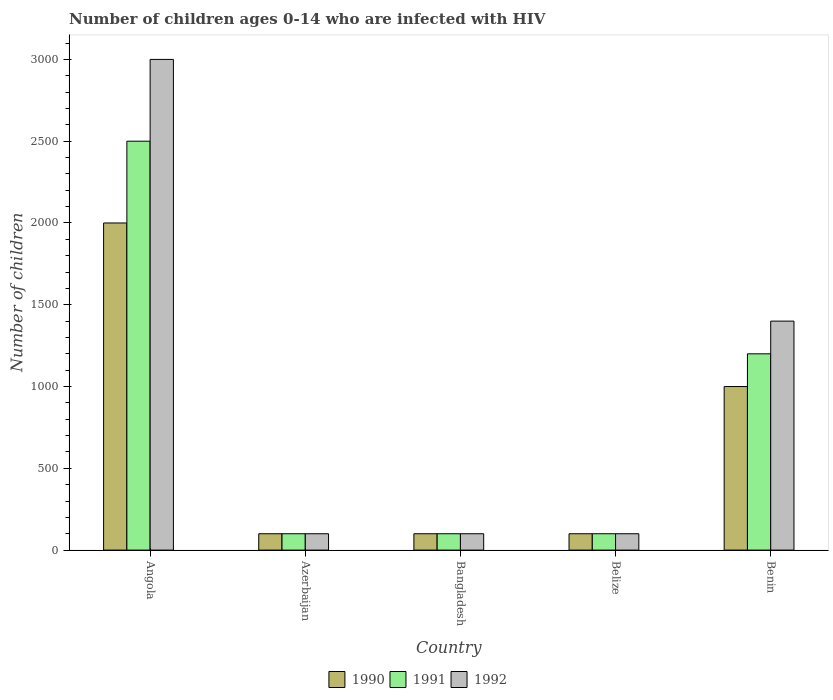How many groups of bars are there?
Your answer should be compact. 5. How many bars are there on the 1st tick from the left?
Your answer should be very brief. 3. How many bars are there on the 2nd tick from the right?
Offer a very short reply. 3. What is the label of the 1st group of bars from the left?
Your response must be concise. Angola. In how many cases, is the number of bars for a given country not equal to the number of legend labels?
Offer a terse response. 0. What is the number of HIV infected children in 1992 in Bangladesh?
Ensure brevity in your answer.  100. Across all countries, what is the maximum number of HIV infected children in 1992?
Give a very brief answer. 3000. Across all countries, what is the minimum number of HIV infected children in 1990?
Give a very brief answer. 100. In which country was the number of HIV infected children in 1990 maximum?
Provide a short and direct response. Angola. In which country was the number of HIV infected children in 1990 minimum?
Keep it short and to the point. Azerbaijan. What is the total number of HIV infected children in 1991 in the graph?
Your answer should be compact. 4000. What is the difference between the number of HIV infected children in 1991 in Angola and that in Azerbaijan?
Your answer should be very brief. 2400. What is the difference between the number of HIV infected children in 1990 in Benin and the number of HIV infected children in 1992 in Bangladesh?
Offer a very short reply. 900. What is the average number of HIV infected children in 1992 per country?
Provide a short and direct response. 940. What is the difference between the number of HIV infected children of/in 1992 and number of HIV infected children of/in 1991 in Belize?
Provide a short and direct response. 0. Is the difference between the number of HIV infected children in 1992 in Azerbaijan and Bangladesh greater than the difference between the number of HIV infected children in 1991 in Azerbaijan and Bangladesh?
Your response must be concise. No. What is the difference between the highest and the second highest number of HIV infected children in 1992?
Give a very brief answer. 2900. What is the difference between the highest and the lowest number of HIV infected children in 1991?
Provide a succinct answer. 2400. In how many countries, is the number of HIV infected children in 1990 greater than the average number of HIV infected children in 1990 taken over all countries?
Your response must be concise. 2. What does the 2nd bar from the right in Azerbaijan represents?
Give a very brief answer. 1991. Is it the case that in every country, the sum of the number of HIV infected children in 1990 and number of HIV infected children in 1991 is greater than the number of HIV infected children in 1992?
Your answer should be very brief. Yes. How many bars are there?
Make the answer very short. 15. Are all the bars in the graph horizontal?
Ensure brevity in your answer.  No. Does the graph contain grids?
Provide a short and direct response. No. Where does the legend appear in the graph?
Provide a succinct answer. Bottom center. How many legend labels are there?
Your answer should be compact. 3. How are the legend labels stacked?
Provide a short and direct response. Horizontal. What is the title of the graph?
Give a very brief answer. Number of children ages 0-14 who are infected with HIV. What is the label or title of the X-axis?
Your response must be concise. Country. What is the label or title of the Y-axis?
Ensure brevity in your answer.  Number of children. What is the Number of children of 1991 in Angola?
Your answer should be compact. 2500. What is the Number of children in 1992 in Angola?
Provide a short and direct response. 3000. What is the Number of children of 1991 in Azerbaijan?
Offer a very short reply. 100. What is the Number of children of 1992 in Azerbaijan?
Provide a short and direct response. 100. What is the Number of children of 1990 in Bangladesh?
Give a very brief answer. 100. What is the Number of children of 1991 in Bangladesh?
Provide a succinct answer. 100. What is the Number of children of 1990 in Belize?
Keep it short and to the point. 100. What is the Number of children in 1991 in Belize?
Make the answer very short. 100. What is the Number of children in 1992 in Belize?
Provide a succinct answer. 100. What is the Number of children of 1991 in Benin?
Give a very brief answer. 1200. What is the Number of children in 1992 in Benin?
Keep it short and to the point. 1400. Across all countries, what is the maximum Number of children in 1990?
Keep it short and to the point. 2000. Across all countries, what is the maximum Number of children of 1991?
Keep it short and to the point. 2500. Across all countries, what is the maximum Number of children of 1992?
Provide a short and direct response. 3000. Across all countries, what is the minimum Number of children in 1991?
Offer a terse response. 100. Across all countries, what is the minimum Number of children of 1992?
Provide a short and direct response. 100. What is the total Number of children of 1990 in the graph?
Provide a succinct answer. 3300. What is the total Number of children in 1991 in the graph?
Keep it short and to the point. 4000. What is the total Number of children of 1992 in the graph?
Your answer should be compact. 4700. What is the difference between the Number of children of 1990 in Angola and that in Azerbaijan?
Offer a terse response. 1900. What is the difference between the Number of children in 1991 in Angola and that in Azerbaijan?
Your answer should be very brief. 2400. What is the difference between the Number of children of 1992 in Angola and that in Azerbaijan?
Ensure brevity in your answer.  2900. What is the difference between the Number of children of 1990 in Angola and that in Bangladesh?
Your response must be concise. 1900. What is the difference between the Number of children in 1991 in Angola and that in Bangladesh?
Give a very brief answer. 2400. What is the difference between the Number of children in 1992 in Angola and that in Bangladesh?
Give a very brief answer. 2900. What is the difference between the Number of children in 1990 in Angola and that in Belize?
Offer a terse response. 1900. What is the difference between the Number of children in 1991 in Angola and that in Belize?
Provide a short and direct response. 2400. What is the difference between the Number of children in 1992 in Angola and that in Belize?
Ensure brevity in your answer.  2900. What is the difference between the Number of children of 1990 in Angola and that in Benin?
Make the answer very short. 1000. What is the difference between the Number of children of 1991 in Angola and that in Benin?
Keep it short and to the point. 1300. What is the difference between the Number of children of 1992 in Angola and that in Benin?
Offer a terse response. 1600. What is the difference between the Number of children in 1990 in Azerbaijan and that in Bangladesh?
Your answer should be very brief. 0. What is the difference between the Number of children of 1991 in Azerbaijan and that in Belize?
Ensure brevity in your answer.  0. What is the difference between the Number of children of 1992 in Azerbaijan and that in Belize?
Ensure brevity in your answer.  0. What is the difference between the Number of children of 1990 in Azerbaijan and that in Benin?
Keep it short and to the point. -900. What is the difference between the Number of children of 1991 in Azerbaijan and that in Benin?
Your response must be concise. -1100. What is the difference between the Number of children of 1992 in Azerbaijan and that in Benin?
Give a very brief answer. -1300. What is the difference between the Number of children in 1990 in Bangladesh and that in Belize?
Your answer should be very brief. 0. What is the difference between the Number of children of 1992 in Bangladesh and that in Belize?
Your answer should be very brief. 0. What is the difference between the Number of children in 1990 in Bangladesh and that in Benin?
Offer a terse response. -900. What is the difference between the Number of children in 1991 in Bangladesh and that in Benin?
Offer a terse response. -1100. What is the difference between the Number of children of 1992 in Bangladesh and that in Benin?
Provide a short and direct response. -1300. What is the difference between the Number of children in 1990 in Belize and that in Benin?
Your answer should be very brief. -900. What is the difference between the Number of children in 1991 in Belize and that in Benin?
Give a very brief answer. -1100. What is the difference between the Number of children in 1992 in Belize and that in Benin?
Ensure brevity in your answer.  -1300. What is the difference between the Number of children of 1990 in Angola and the Number of children of 1991 in Azerbaijan?
Provide a short and direct response. 1900. What is the difference between the Number of children in 1990 in Angola and the Number of children in 1992 in Azerbaijan?
Keep it short and to the point. 1900. What is the difference between the Number of children in 1991 in Angola and the Number of children in 1992 in Azerbaijan?
Offer a very short reply. 2400. What is the difference between the Number of children of 1990 in Angola and the Number of children of 1991 in Bangladesh?
Offer a very short reply. 1900. What is the difference between the Number of children in 1990 in Angola and the Number of children in 1992 in Bangladesh?
Offer a terse response. 1900. What is the difference between the Number of children of 1991 in Angola and the Number of children of 1992 in Bangladesh?
Provide a succinct answer. 2400. What is the difference between the Number of children of 1990 in Angola and the Number of children of 1991 in Belize?
Keep it short and to the point. 1900. What is the difference between the Number of children of 1990 in Angola and the Number of children of 1992 in Belize?
Give a very brief answer. 1900. What is the difference between the Number of children of 1991 in Angola and the Number of children of 1992 in Belize?
Your response must be concise. 2400. What is the difference between the Number of children in 1990 in Angola and the Number of children in 1991 in Benin?
Ensure brevity in your answer.  800. What is the difference between the Number of children in 1990 in Angola and the Number of children in 1992 in Benin?
Your answer should be compact. 600. What is the difference between the Number of children in 1991 in Angola and the Number of children in 1992 in Benin?
Offer a terse response. 1100. What is the difference between the Number of children in 1990 in Azerbaijan and the Number of children in 1992 in Bangladesh?
Your answer should be compact. 0. What is the difference between the Number of children of 1991 in Azerbaijan and the Number of children of 1992 in Bangladesh?
Your answer should be very brief. 0. What is the difference between the Number of children in 1990 in Azerbaijan and the Number of children in 1991 in Belize?
Make the answer very short. 0. What is the difference between the Number of children of 1990 in Azerbaijan and the Number of children of 1992 in Belize?
Offer a terse response. 0. What is the difference between the Number of children of 1991 in Azerbaijan and the Number of children of 1992 in Belize?
Give a very brief answer. 0. What is the difference between the Number of children in 1990 in Azerbaijan and the Number of children in 1991 in Benin?
Your answer should be very brief. -1100. What is the difference between the Number of children of 1990 in Azerbaijan and the Number of children of 1992 in Benin?
Ensure brevity in your answer.  -1300. What is the difference between the Number of children in 1991 in Azerbaijan and the Number of children in 1992 in Benin?
Ensure brevity in your answer.  -1300. What is the difference between the Number of children in 1990 in Bangladesh and the Number of children in 1991 in Belize?
Give a very brief answer. 0. What is the difference between the Number of children of 1990 in Bangladesh and the Number of children of 1992 in Belize?
Provide a succinct answer. 0. What is the difference between the Number of children of 1990 in Bangladesh and the Number of children of 1991 in Benin?
Provide a succinct answer. -1100. What is the difference between the Number of children in 1990 in Bangladesh and the Number of children in 1992 in Benin?
Provide a succinct answer. -1300. What is the difference between the Number of children of 1991 in Bangladesh and the Number of children of 1992 in Benin?
Give a very brief answer. -1300. What is the difference between the Number of children of 1990 in Belize and the Number of children of 1991 in Benin?
Give a very brief answer. -1100. What is the difference between the Number of children in 1990 in Belize and the Number of children in 1992 in Benin?
Your answer should be very brief. -1300. What is the difference between the Number of children of 1991 in Belize and the Number of children of 1992 in Benin?
Make the answer very short. -1300. What is the average Number of children of 1990 per country?
Keep it short and to the point. 660. What is the average Number of children in 1991 per country?
Keep it short and to the point. 800. What is the average Number of children of 1992 per country?
Provide a succinct answer. 940. What is the difference between the Number of children of 1990 and Number of children of 1991 in Angola?
Provide a succinct answer. -500. What is the difference between the Number of children in 1990 and Number of children in 1992 in Angola?
Your answer should be compact. -1000. What is the difference between the Number of children in 1991 and Number of children in 1992 in Angola?
Keep it short and to the point. -500. What is the difference between the Number of children in 1990 and Number of children in 1992 in Bangladesh?
Provide a succinct answer. 0. What is the difference between the Number of children in 1990 and Number of children in 1992 in Belize?
Keep it short and to the point. 0. What is the difference between the Number of children in 1990 and Number of children in 1991 in Benin?
Give a very brief answer. -200. What is the difference between the Number of children of 1990 and Number of children of 1992 in Benin?
Your response must be concise. -400. What is the difference between the Number of children of 1991 and Number of children of 1992 in Benin?
Provide a short and direct response. -200. What is the ratio of the Number of children of 1990 in Angola to that in Azerbaijan?
Provide a succinct answer. 20. What is the ratio of the Number of children of 1991 in Angola to that in Azerbaijan?
Offer a very short reply. 25. What is the ratio of the Number of children in 1992 in Angola to that in Azerbaijan?
Keep it short and to the point. 30. What is the ratio of the Number of children of 1991 in Angola to that in Bangladesh?
Make the answer very short. 25. What is the ratio of the Number of children of 1992 in Angola to that in Bangladesh?
Offer a terse response. 30. What is the ratio of the Number of children in 1990 in Angola to that in Belize?
Offer a very short reply. 20. What is the ratio of the Number of children of 1991 in Angola to that in Belize?
Your response must be concise. 25. What is the ratio of the Number of children of 1991 in Angola to that in Benin?
Offer a very short reply. 2.08. What is the ratio of the Number of children of 1992 in Angola to that in Benin?
Keep it short and to the point. 2.14. What is the ratio of the Number of children in 1990 in Azerbaijan to that in Belize?
Your answer should be compact. 1. What is the ratio of the Number of children of 1991 in Azerbaijan to that in Belize?
Ensure brevity in your answer.  1. What is the ratio of the Number of children in 1992 in Azerbaijan to that in Belize?
Make the answer very short. 1. What is the ratio of the Number of children of 1991 in Azerbaijan to that in Benin?
Provide a short and direct response. 0.08. What is the ratio of the Number of children in 1992 in Azerbaijan to that in Benin?
Provide a succinct answer. 0.07. What is the ratio of the Number of children of 1990 in Bangladesh to that in Belize?
Ensure brevity in your answer.  1. What is the ratio of the Number of children of 1991 in Bangladesh to that in Belize?
Offer a terse response. 1. What is the ratio of the Number of children of 1990 in Bangladesh to that in Benin?
Keep it short and to the point. 0.1. What is the ratio of the Number of children of 1991 in Bangladesh to that in Benin?
Provide a short and direct response. 0.08. What is the ratio of the Number of children of 1992 in Bangladesh to that in Benin?
Your answer should be very brief. 0.07. What is the ratio of the Number of children of 1991 in Belize to that in Benin?
Keep it short and to the point. 0.08. What is the ratio of the Number of children of 1992 in Belize to that in Benin?
Your answer should be compact. 0.07. What is the difference between the highest and the second highest Number of children in 1990?
Provide a short and direct response. 1000. What is the difference between the highest and the second highest Number of children in 1991?
Offer a terse response. 1300. What is the difference between the highest and the second highest Number of children of 1992?
Offer a very short reply. 1600. What is the difference between the highest and the lowest Number of children in 1990?
Make the answer very short. 1900. What is the difference between the highest and the lowest Number of children of 1991?
Provide a short and direct response. 2400. What is the difference between the highest and the lowest Number of children in 1992?
Ensure brevity in your answer.  2900. 